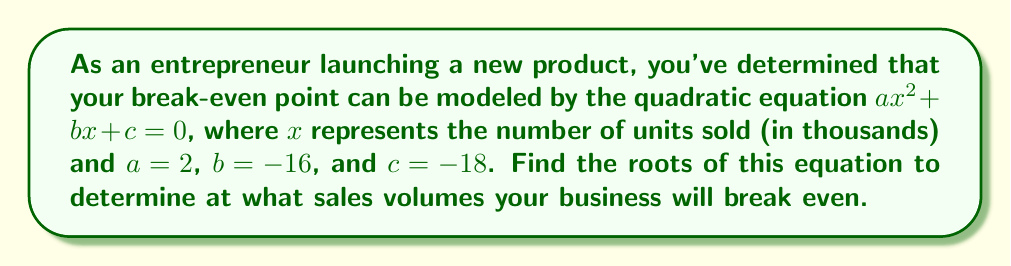What is the answer to this math problem? To find the roots of the quadratic equation, we'll use the quadratic formula:

$$x = \frac{-b \pm \sqrt{b^2 - 4ac}}{2a}$$

Given:
$a = 2$
$b = -16$
$c = -18$

Step 1: Calculate the discriminant ($b^2 - 4ac$)
$$b^2 - 4ac = (-16)^2 - 4(2)(-18) = 256 + 144 = 400$$

Step 2: Substitute values into the quadratic formula
$$x = \frac{-(-16) \pm \sqrt{400}}{2(2)}$$
$$x = \frac{16 \pm 20}{4}$$

Step 3: Solve for both roots
Positive root: $x_1 = \frac{16 + 20}{4} = \frac{36}{4} = 9$
Negative root: $x_2 = \frac{16 - 20}{4} = \frac{-4}{4} = -1$

Step 4: Interpret the results
The positive root (9) represents a realistic break-even point of 9,000 units sold. The negative root (-1) can be disregarded in this context as it's not possible to sell a negative number of units.
Answer: The break-even point occurs at 9,000 units sold. 